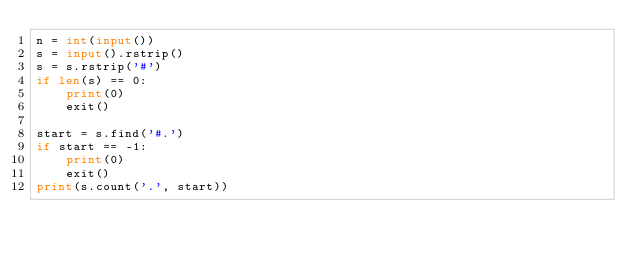Convert code to text. <code><loc_0><loc_0><loc_500><loc_500><_Python_>n = int(input())
s = input().rstrip()
s = s.rstrip('#')
if len(s) == 0:
    print(0)
    exit()

start = s.find('#.')
if start == -1:
    print(0)
    exit()
print(s.count('.', start))</code> 